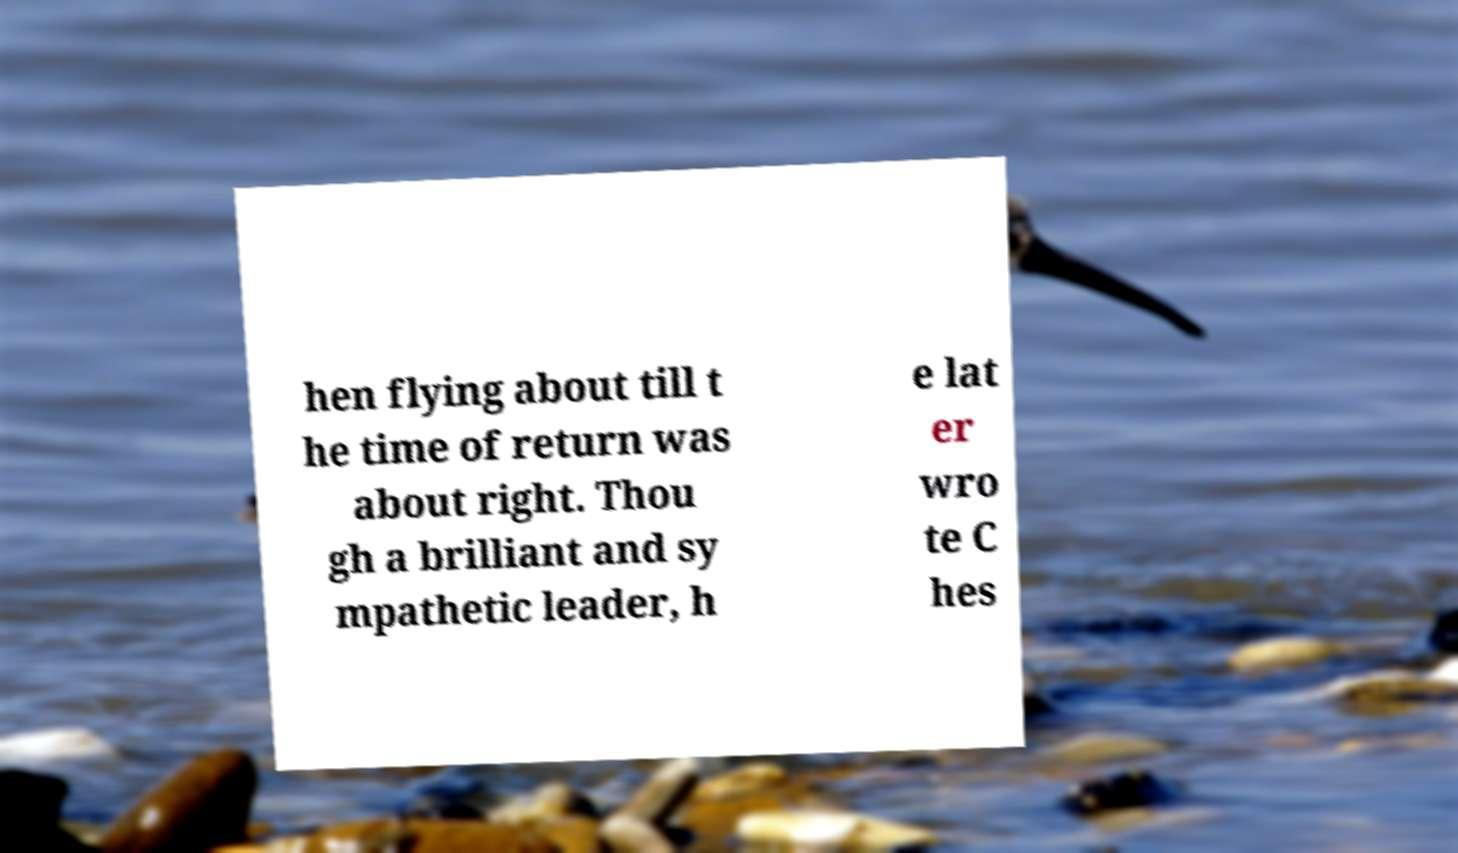Could you extract and type out the text from this image? hen flying about till t he time of return was about right. Thou gh a brilliant and sy mpathetic leader, h e lat er wro te C hes 